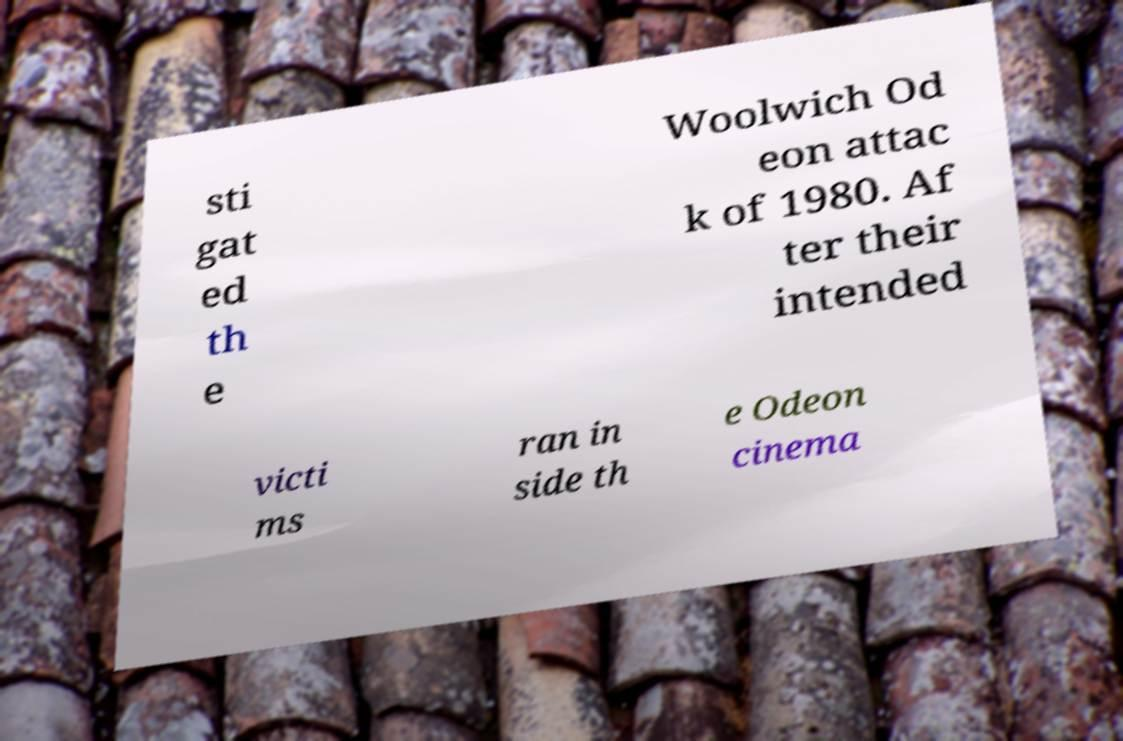Could you assist in decoding the text presented in this image and type it out clearly? sti gat ed th e Woolwich Od eon attac k of 1980. Af ter their intended victi ms ran in side th e Odeon cinema 